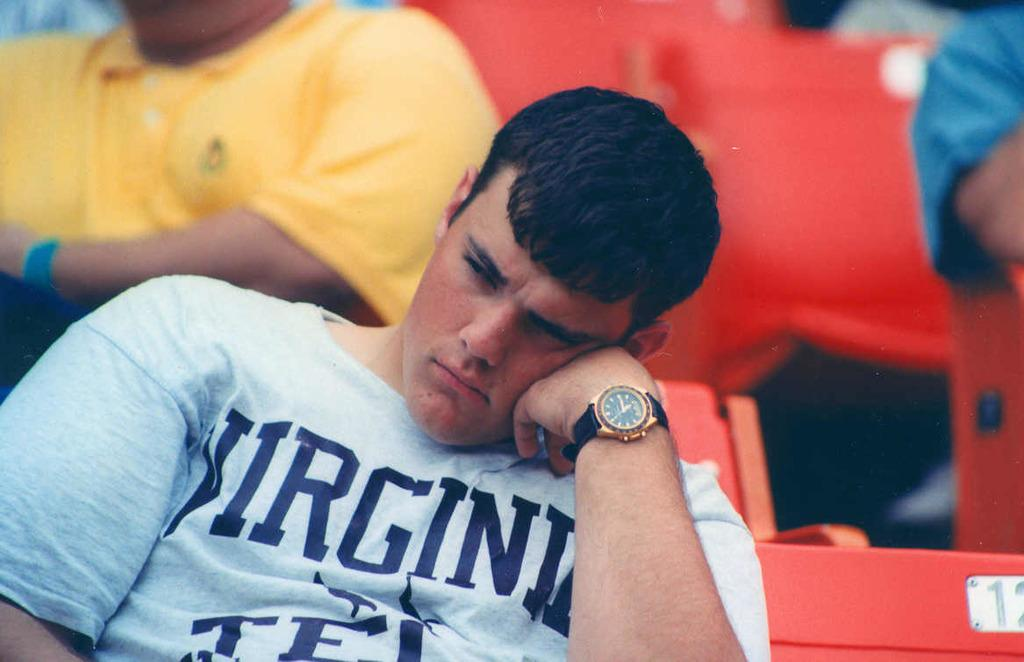Provide a one-sentence caption for the provided image. A young man is wearing a Virginia shirt and rests his head on his hand. 